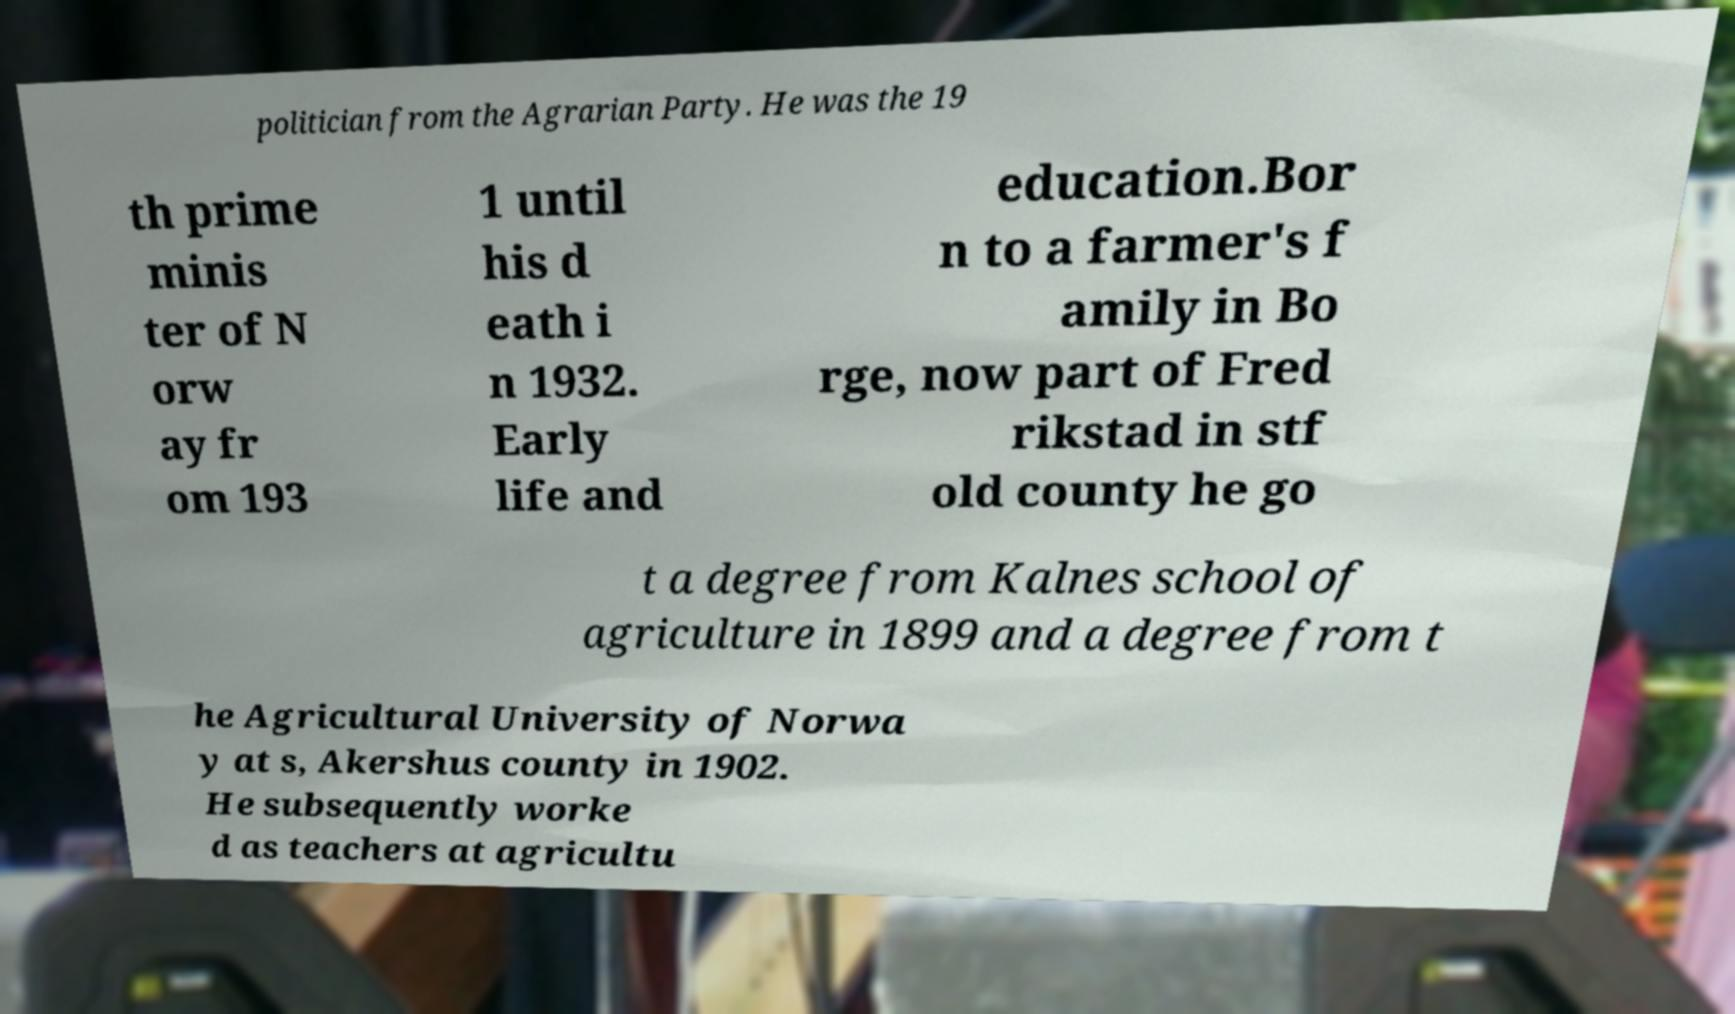Could you extract and type out the text from this image? politician from the Agrarian Party. He was the 19 th prime minis ter of N orw ay fr om 193 1 until his d eath i n 1932. Early life and education.Bor n to a farmer's f amily in Bo rge, now part of Fred rikstad in stf old county he go t a degree from Kalnes school of agriculture in 1899 and a degree from t he Agricultural University of Norwa y at s, Akershus county in 1902. He subsequently worke d as teachers at agricultu 